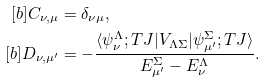Convert formula to latex. <formula><loc_0><loc_0><loc_500><loc_500>[ b ] C _ { \nu , \mu } & = \delta _ { \nu \mu } , \\ [ b ] D _ { \nu , \mu ^ { \prime } } & = - \frac { \langle \psi _ { \nu } ^ { \Lambda } ; T J | V _ { \Lambda \Sigma } | \psi _ { \mu ^ { \prime } } ^ { \Sigma } ; T J \rangle } { E _ { \mu ^ { \prime } } ^ { \Sigma } - E _ { \nu } ^ { \Lambda } } .</formula> 